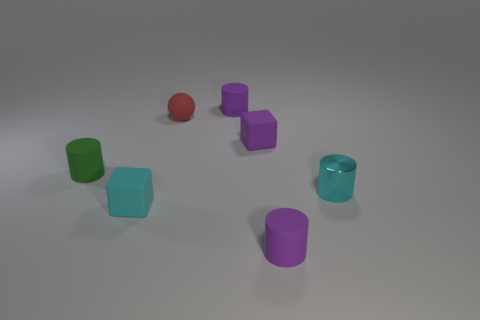There is a purple thing that is in front of the small cyan metallic thing; is it the same shape as the cyan metal thing?
Provide a succinct answer. Yes. Are there any purple cubes?
Give a very brief answer. Yes. There is a cube right of the small purple matte object behind the tiny cube on the right side of the tiny cyan block; what color is it?
Offer a terse response. Purple. Are there the same number of purple rubber objects in front of the tiny purple rubber cube and tiny balls to the left of the sphere?
Your response must be concise. No. There is a cyan matte thing that is the same size as the purple block; what shape is it?
Your response must be concise. Cube. Is there a small object that has the same color as the ball?
Offer a very short reply. No. What shape is the purple matte object behind the tiny sphere?
Your answer should be compact. Cylinder. The shiny object is what color?
Ensure brevity in your answer.  Cyan. The other cube that is made of the same material as the tiny cyan cube is what color?
Provide a succinct answer. Purple. What number of tiny things have the same material as the green cylinder?
Keep it short and to the point. 5. 